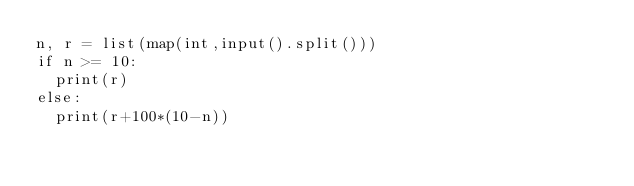<code> <loc_0><loc_0><loc_500><loc_500><_Python_>n, r = list(map(int,input().split()))
if n >= 10:
  print(r)
else:
  print(r+100*(10-n))</code> 